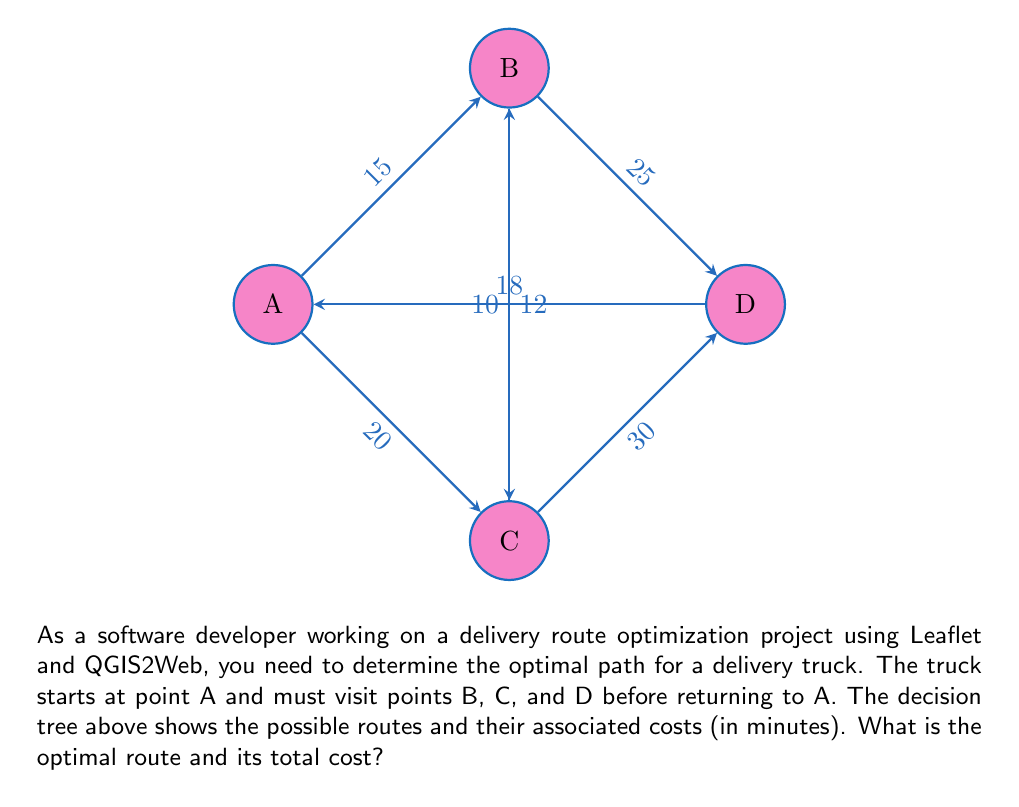Can you answer this question? To solve this problem, we'll use a decision tree approach:

1) First, we need to list all possible routes:
   A-B-C-D-A
   A-B-D-C-A
   A-C-B-D-A
   A-C-D-B-A

2) Now, let's calculate the cost for each route:

   A-B-C-D-A:
   $15 + 10 + 30 + 18 = 73$ minutes

   A-B-D-C-A:
   $15 + 25 + 30 + 18 = 88$ minutes

   A-C-B-D-A:
   $20 + 12 + 25 + 18 = 75$ minutes

   A-C-D-B-A:
   $20 + 30 + 25 + 18 = 93$ minutes

3) The optimal route is the one with the lowest total cost. From our calculations, we can see that the route A-B-C-D-A has the lowest cost of 73 minutes.

4) Therefore, the optimal path for the delivery truck is to go from A to B, then to C, then to D, and finally back to A.
Answer: A-B-C-D-A, 73 minutes 